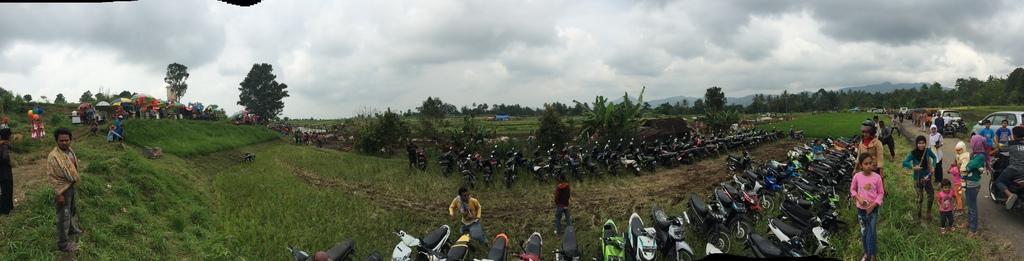Please provide a concise description of this image. In this picture there is a view of the big ground. In the front there are many bikes parked in the ground. On the right side there is a group of girls standing and a giving pose. In the background there are many trees. On the left side we can see some small shops with colorful umbrella sheds. 